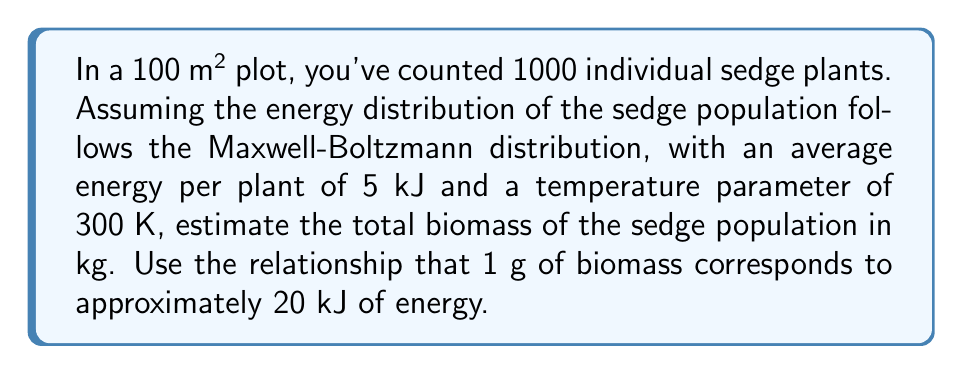What is the answer to this math problem? To solve this problem, we'll use concepts from statistical mechanics and the given information:

1) The Maxwell-Boltzmann distribution describes the energy distribution in the system. The average energy per plant is given as 5 kJ.

2) We know the number of plants: N = 1000

3) First, calculate the total energy of the system:
   $$E_{total} = N \times E_{average} = 1000 \times 5 \text{ kJ} = 5000 \text{ kJ}$$

4) Now, we need to convert this energy to biomass. We're given that 1 g of biomass corresponds to 20 kJ of energy. Let's set up the conversion:
   $$\frac{5000 \text{ kJ}}{20 \text{ kJ/g}} = 250 \text{ g}$$

5) Convert grams to kilograms:
   $$250 \text{ g} \times \frac{1 \text{ kg}}{1000 \text{ g}} = 0.25 \text{ kg}$$

Therefore, the estimated biomass of the sedge population is 0.25 kg.

Note: In this simplified model, we didn't directly use the temperature parameter or the specific form of the Maxwell-Boltzmann distribution. In a more complex analysis, these factors could influence the energy distribution and thus the biomass estimate.
Answer: 0.25 kg 